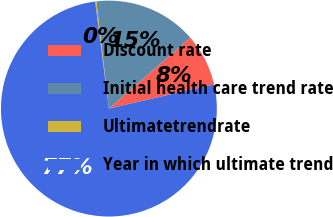Convert chart to OTSL. <chart><loc_0><loc_0><loc_500><loc_500><pie_chart><fcel>Discount rate<fcel>Initial health care trend rate<fcel>Ultimatetrendrate<fcel>Year in which ultimate trend<nl><fcel>7.81%<fcel>15.45%<fcel>0.17%<fcel>76.57%<nl></chart> 